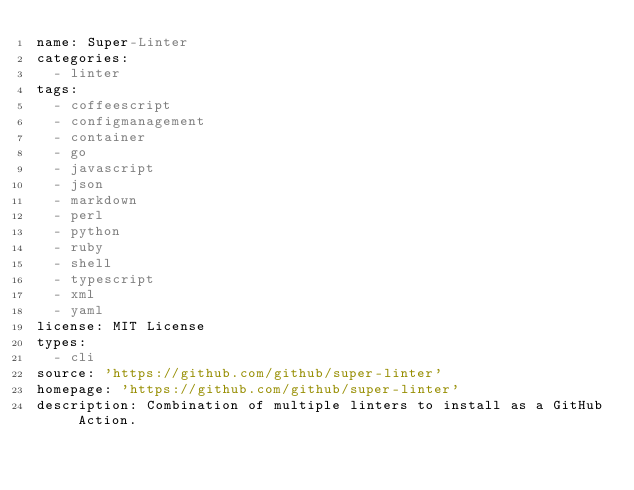<code> <loc_0><loc_0><loc_500><loc_500><_YAML_>name: Super-Linter
categories:
  - linter
tags:
  - coffeescript
  - configmanagement
  - container
  - go
  - javascript
  - json
  - markdown
  - perl
  - python
  - ruby
  - shell
  - typescript
  - xml
  - yaml
license: MIT License
types:
  - cli
source: 'https://github.com/github/super-linter'
homepage: 'https://github.com/github/super-linter'
description: Combination of multiple linters to install as a GitHub Action.
</code> 